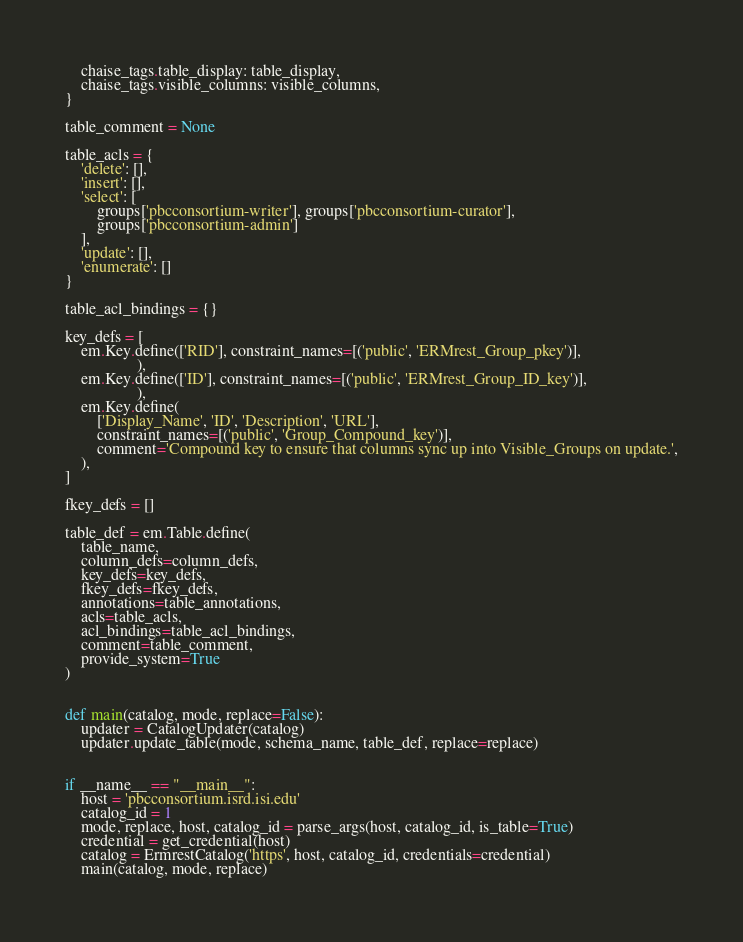Convert code to text. <code><loc_0><loc_0><loc_500><loc_500><_Python_>    chaise_tags.table_display: table_display,
    chaise_tags.visible_columns: visible_columns,
}

table_comment = None

table_acls = {
    'delete': [],
    'insert': [],
    'select': [
        groups['pbcconsortium-writer'], groups['pbcconsortium-curator'],
        groups['pbcconsortium-admin']
    ],
    'update': [],
    'enumerate': []
}

table_acl_bindings = {}

key_defs = [
    em.Key.define(['RID'], constraint_names=[('public', 'ERMrest_Group_pkey')],
                  ),
    em.Key.define(['ID'], constraint_names=[('public', 'ERMrest_Group_ID_key')],
                  ),
    em.Key.define(
        ['Display_Name', 'ID', 'Description', 'URL'],
        constraint_names=[('public', 'Group_Compound_key')],
        comment='Compound key to ensure that columns sync up into Visible_Groups on update.',
    ),
]

fkey_defs = []

table_def = em.Table.define(
    table_name,
    column_defs=column_defs,
    key_defs=key_defs,
    fkey_defs=fkey_defs,
    annotations=table_annotations,
    acls=table_acls,
    acl_bindings=table_acl_bindings,
    comment=table_comment,
    provide_system=True
)


def main(catalog, mode, replace=False):
    updater = CatalogUpdater(catalog)
    updater.update_table(mode, schema_name, table_def, replace=replace)


if __name__ == "__main__":
    host = 'pbcconsortium.isrd.isi.edu'
    catalog_id = 1
    mode, replace, host, catalog_id = parse_args(host, catalog_id, is_table=True)
    credential = get_credential(host)
    catalog = ErmrestCatalog('https', host, catalog_id, credentials=credential)
    main(catalog, mode, replace)

</code> 